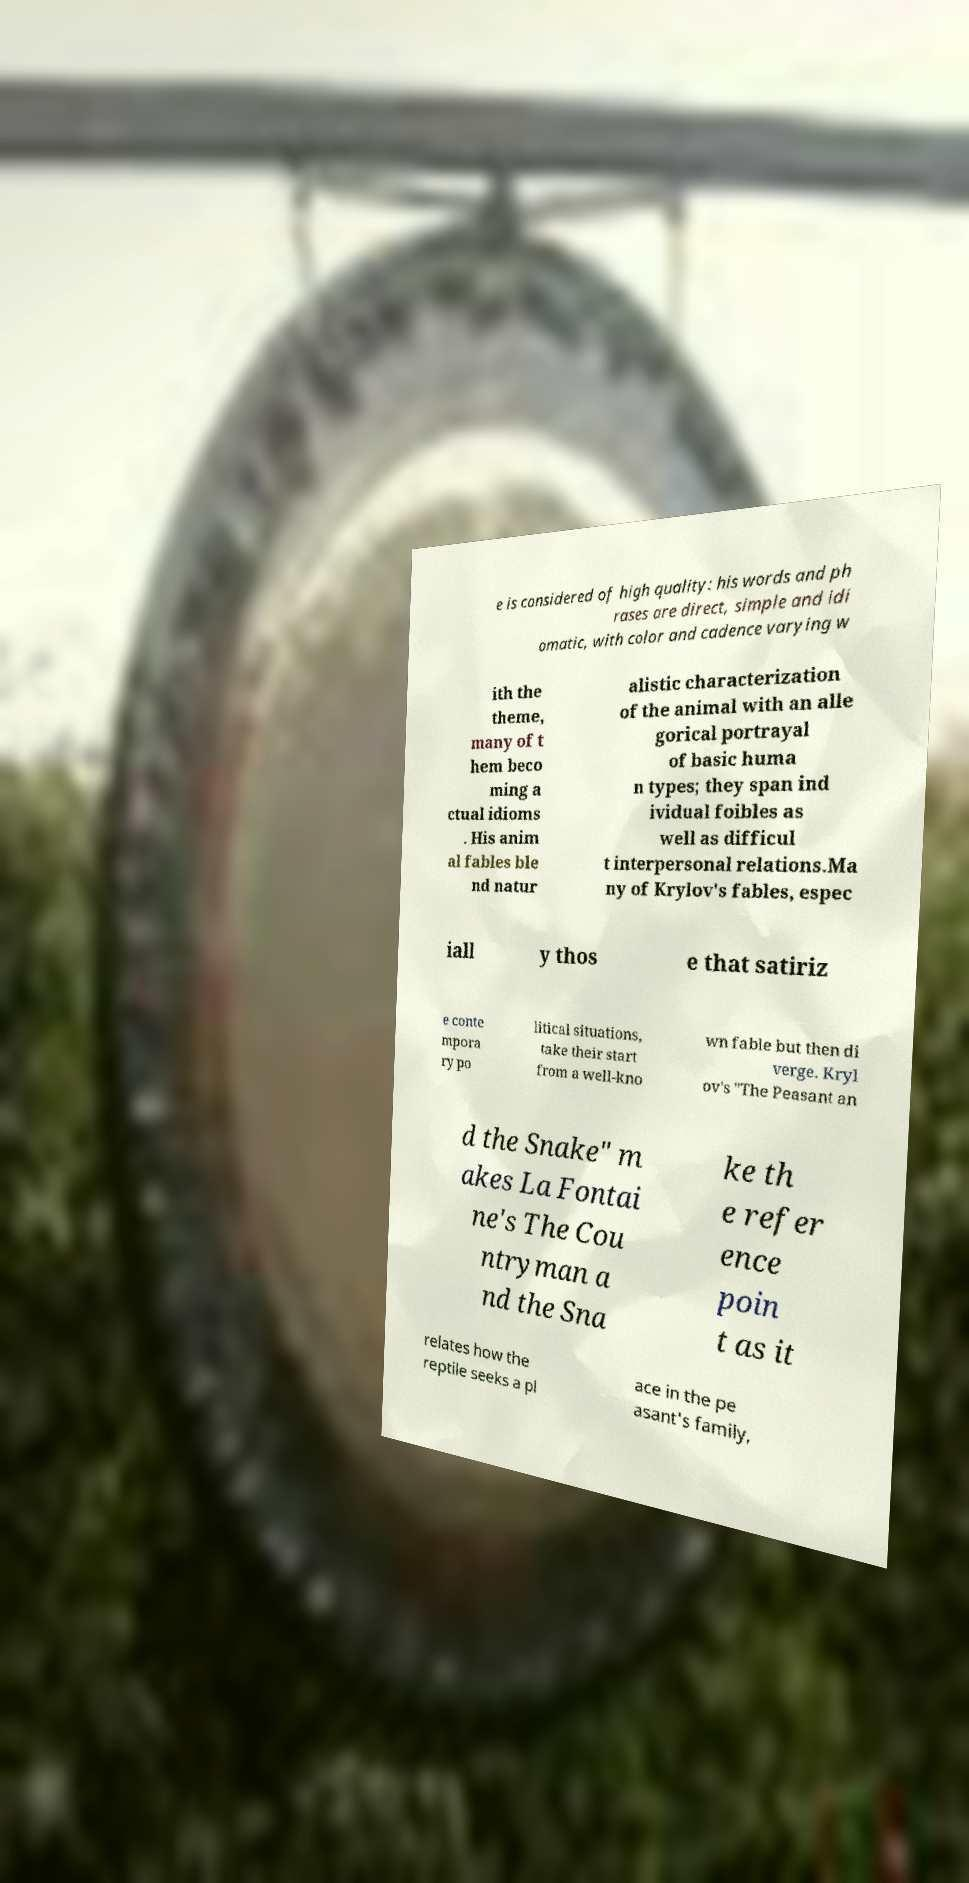Please read and relay the text visible in this image. What does it say? e is considered of high quality: his words and ph rases are direct, simple and idi omatic, with color and cadence varying w ith the theme, many of t hem beco ming a ctual idioms . His anim al fables ble nd natur alistic characterization of the animal with an alle gorical portrayal of basic huma n types; they span ind ividual foibles as well as difficul t interpersonal relations.Ma ny of Krylov's fables, espec iall y thos e that satiriz e conte mpora ry po litical situations, take their start from a well-kno wn fable but then di verge. Kryl ov's "The Peasant an d the Snake" m akes La Fontai ne's The Cou ntryman a nd the Sna ke th e refer ence poin t as it relates how the reptile seeks a pl ace in the pe asant's family, 